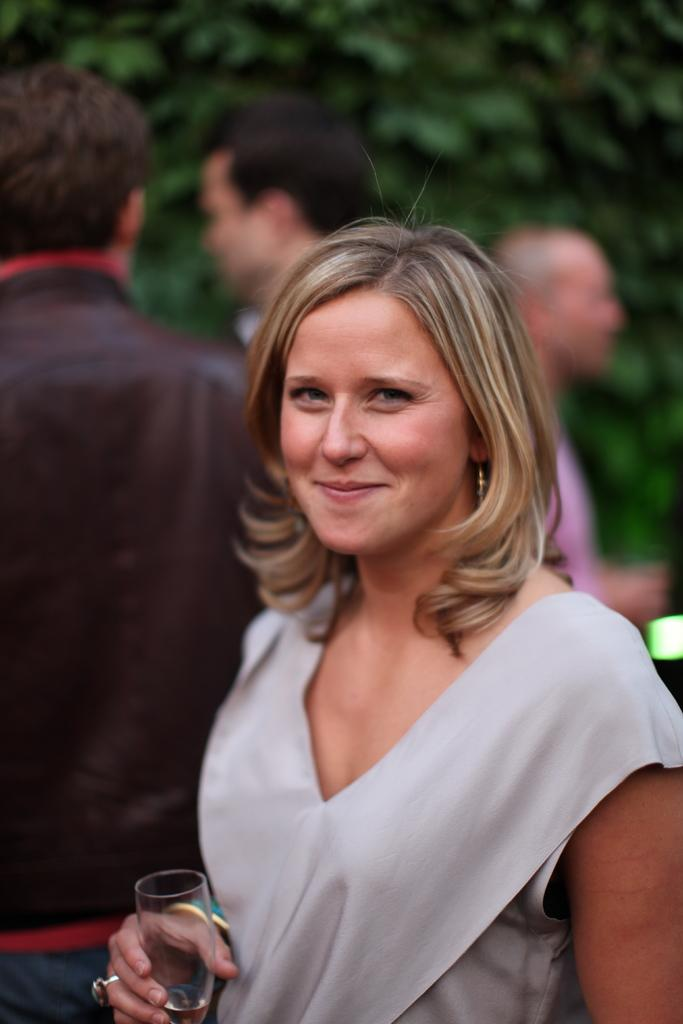What is the woman doing in the image? The woman is standing and smiling in the image. What is the woman holding in her hand? The woman is holding a glass in her hand. What can be seen in the background of the image? There is a group of persons and a tree in the background. What type of dog can be seen playing with an icicle in the image? There is no dog or icicle present in the image; it features a woman standing and smiling while holding a glass. 